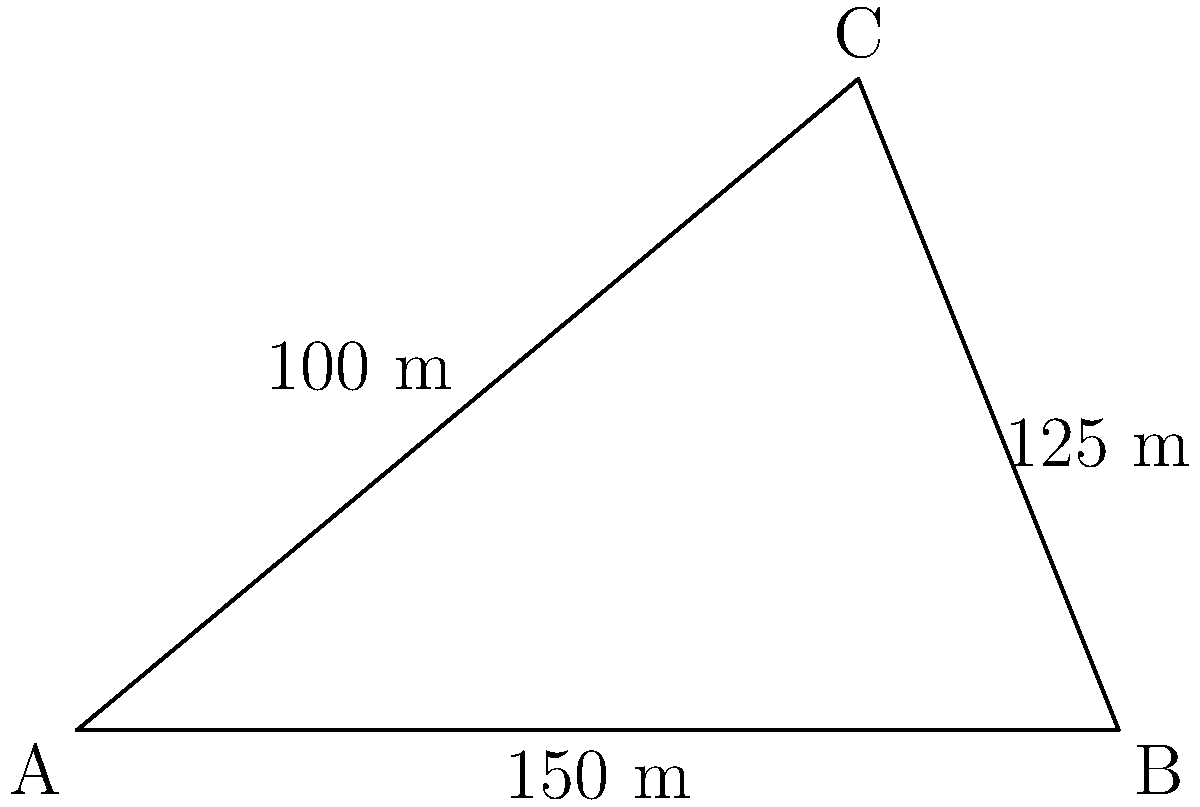You need to calculate the area of an irregular-shaped drill site using triangulation methods. The site forms a triangle with sides measuring 150 m, 125 m, and 100 m. What is the area of the drill site in square meters? To calculate the area of the triangular drill site, we can use Heron's formula:

1) Heron's formula states that the area $A$ of a triangle with sides $a$, $b$, and $c$ is:

   $A = \sqrt{s(s-a)(s-b)(s-c)}$

   where $s$ is the semi-perimeter: $s = \frac{a+b+c}{2}$

2) In this case, $a = 150$ m, $b = 125$ m, and $c = 100$ m

3) Calculate the semi-perimeter:
   $s = \frac{150 + 125 + 100}{2} = \frac{375}{2} = 187.5$ m

4) Now, substitute these values into Heron's formula:

   $A = \sqrt{187.5(187.5-150)(187.5-125)(187.5-100)}$

5) Simplify:
   $A = \sqrt{187.5 \times 37.5 \times 62.5 \times 87.5}$

6) Calculate:
   $A = \sqrt{38,085,937.5} \approx 6174.9$ m²

Therefore, the area of the drill site is approximately 6174.9 square meters.
Answer: 6174.9 m² 